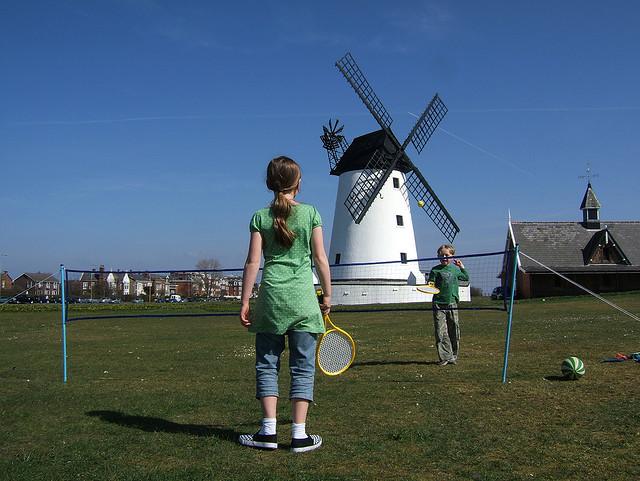What sport are these children playing?
Keep it brief. Badminton. What is the large object in the background?
Short answer required. Windmill. What is the most prominent color in photo?
Be succinct. Blue. 